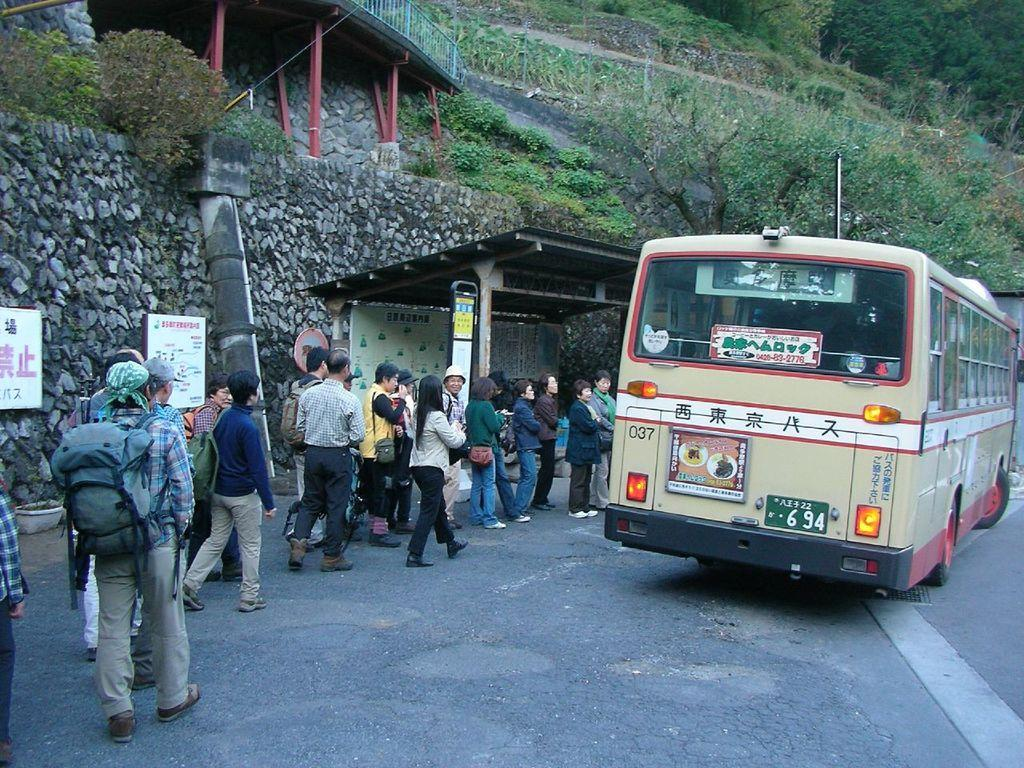What is the main subject of the image? There is a bus in the image. What else can be seen in the image besides the bus? There are people standing in the image, and they are wearing clothes. Can you describe the structure in the middle of the image? There is a shelter in the middle of the image. What type of vegetation is on the right side of the image? There is a tree on the right side of the image. What type of force is being applied to the bus in the image? There is no indication of any force being applied to the bus in the image. Can you tell me how many boats are visible in the image? There are no boats present in the image; it features a bus, people, a shelter, and a tree. 